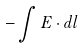Convert formula to latex. <formula><loc_0><loc_0><loc_500><loc_500>- \int E \cdot d l</formula> 